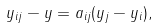Convert formula to latex. <formula><loc_0><loc_0><loc_500><loc_500>y _ { i j } - y = a _ { i j } ( y _ { j } - y _ { i } ) ,</formula> 